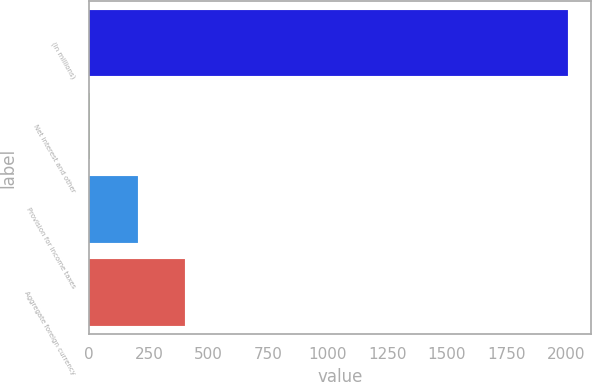Convert chart. <chart><loc_0><loc_0><loc_500><loc_500><bar_chart><fcel>(In millions)<fcel>Net interest and other<fcel>Provision for income taxes<fcel>Aggregate foreign currency<nl><fcel>2007<fcel>2<fcel>202.5<fcel>403<nl></chart> 